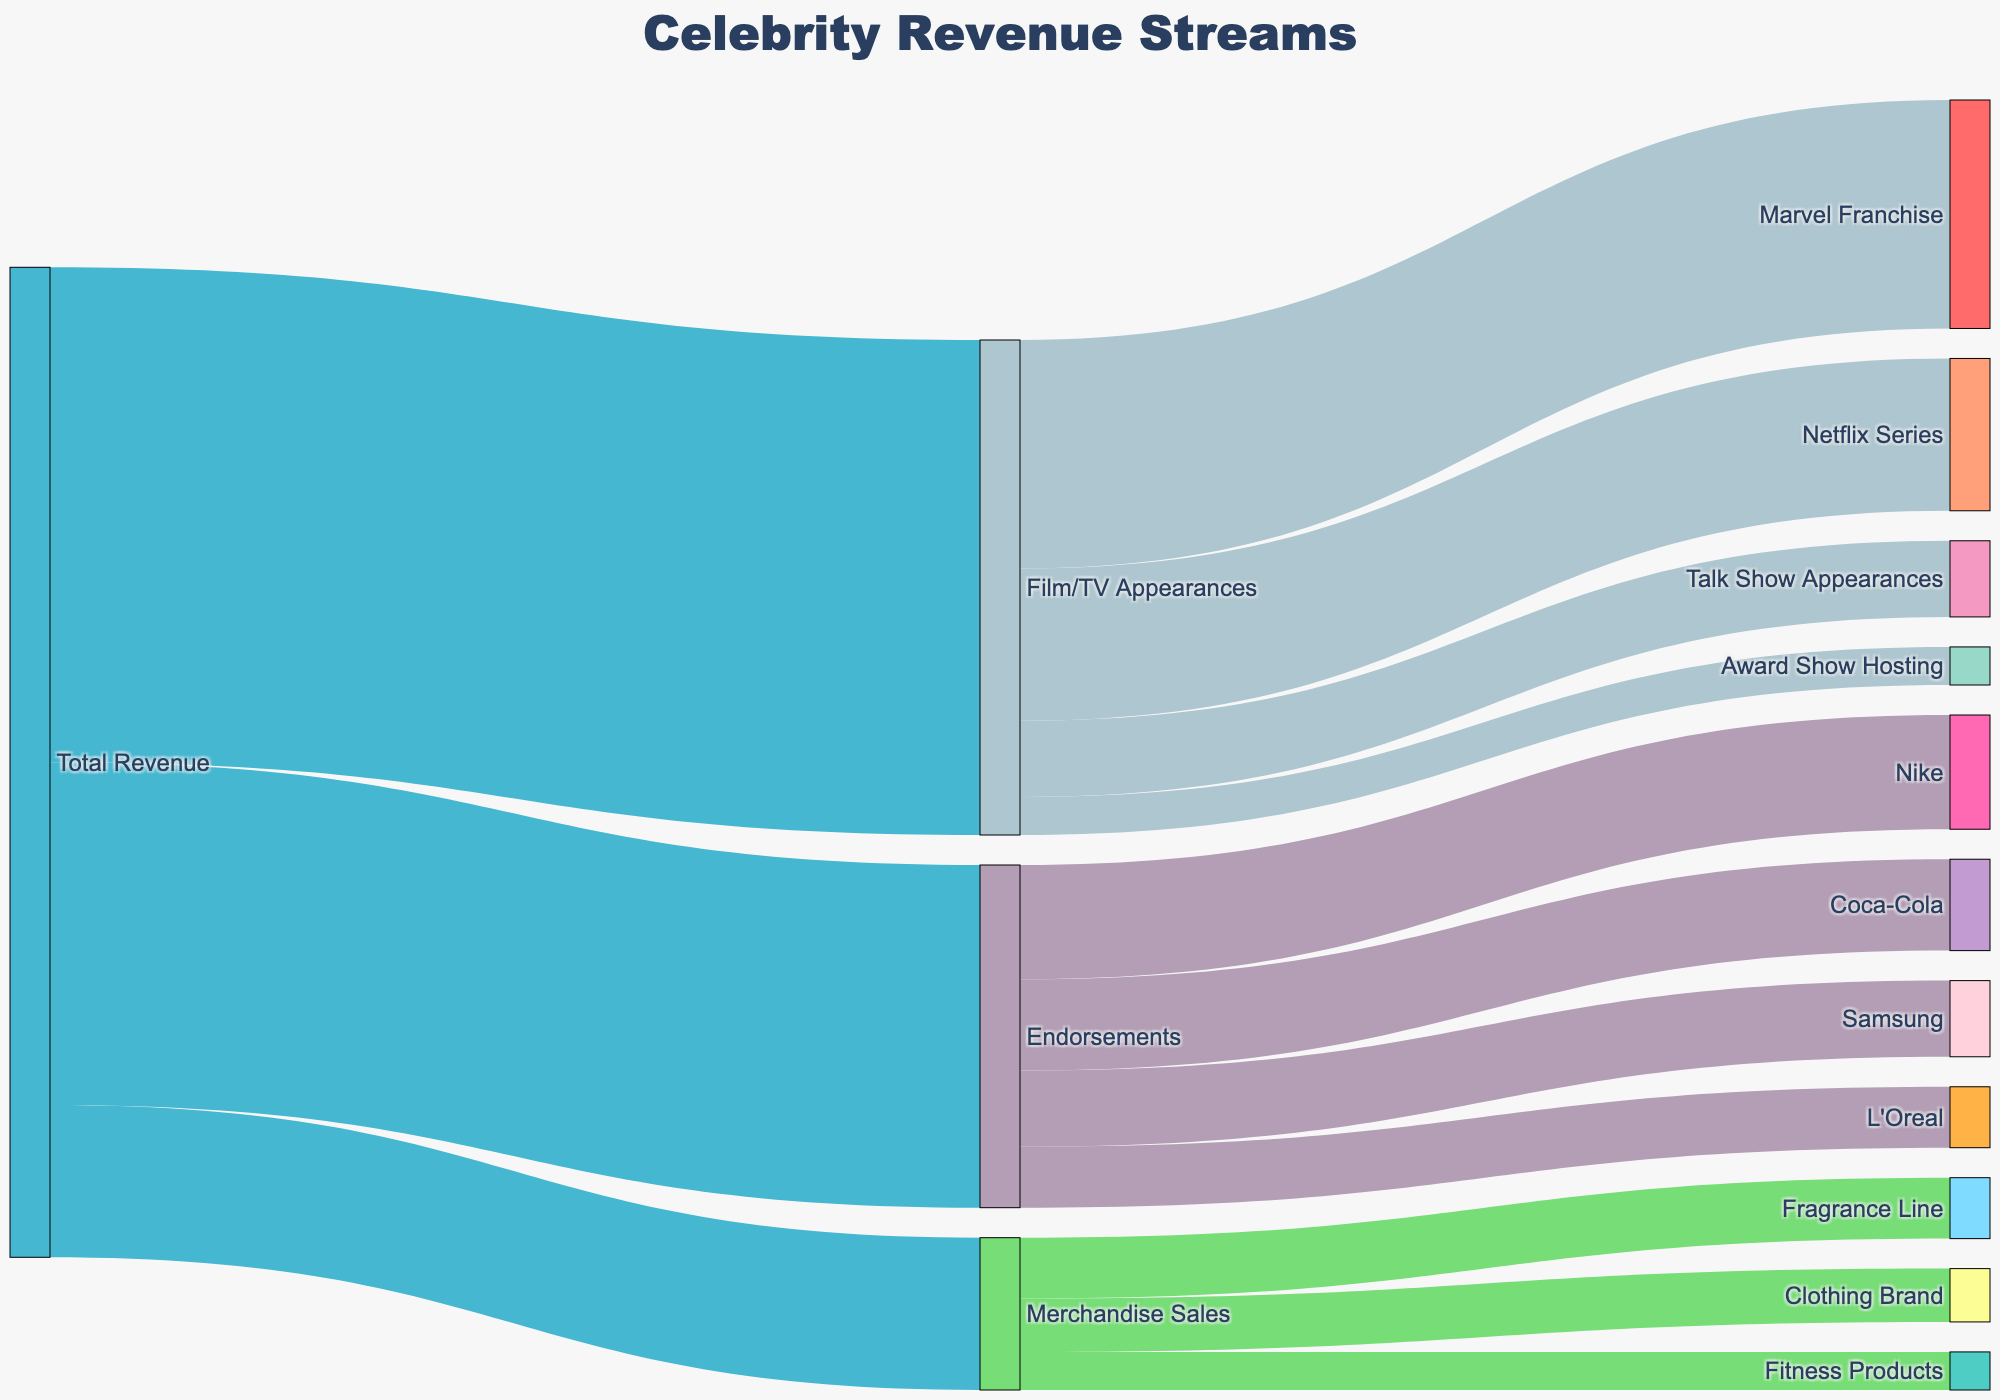What's the title of the Sankey Diagram? The title is located at the top center of the Sankey Diagram and is prominently displayed.
Answer: Celebrity Revenue Streams What is the total revenue depicted in the diagram? The total revenue can be deduced by adding up the values of the primary sources, which are endorsements, film/TV appearances, and merchandise sales: 45,000,000 + 65,000,000 + 20,000,000.
Answer: 130,000,000 Which endorsement contributes the most to the revenue? From the 'Endorsements' segment, compare the values of the revenue streams. The highest value is 15,000,000 from Nike.
Answer: Nike What is the combined revenue from Marvel Franchise and Netflix Series? Add the values from 'Marvel Franchise' (30,000,000) and 'Netflix Series' (20,000,000).
Answer: 50,000,000 Which category between endorsements and merchandise sales has a higher total revenue, and by how much? Compare the total revenue from 'Endorsements' (45,000,000) and 'Merchandise Sales' (20,000,000). The difference is 45,000,000 - 20,000,000.
Answer: Endorsements by 25,000,000 Which segment under Merchandise Sales generates the least revenue? Look at the values under 'Merchandise Sales': 'Fragrance Line' (8,000,000), 'Clothing Brand' (7,000,000), 'Fitness Products' (5,000,000). 'Fitness Products' has the smallest value.
Answer: Fitness Products What portion of the total revenue comes from Endorsements? Calculate the fraction of the total revenue from 'Endorsements': 45,000,000 / 130,000,000, then convert to a percentage.
Answer: 34.6% How much more revenue do Film/TV Appearances generate compared to Merchandise Sales? Subtract the revenue from 'Merchandise Sales' (20,000,000) from 'Film/TV Appearances' (65,000,000).
Answer: 45,000,000 Summarize the total revenue earned from award show hosting and talk show appearances. Add the values from 'Award Show Hosting' (5,000,000) and 'Talk Show Appearances' (10,000,000).
Answer: 15,000,000 If you combine the revenue from endorsements made by Coca-Cola and Samsung, how much is it? Add the values from 'Coca-Cola' (12,000,000) and 'Samsung' (10,000,000).
Answer: 22,000,000 